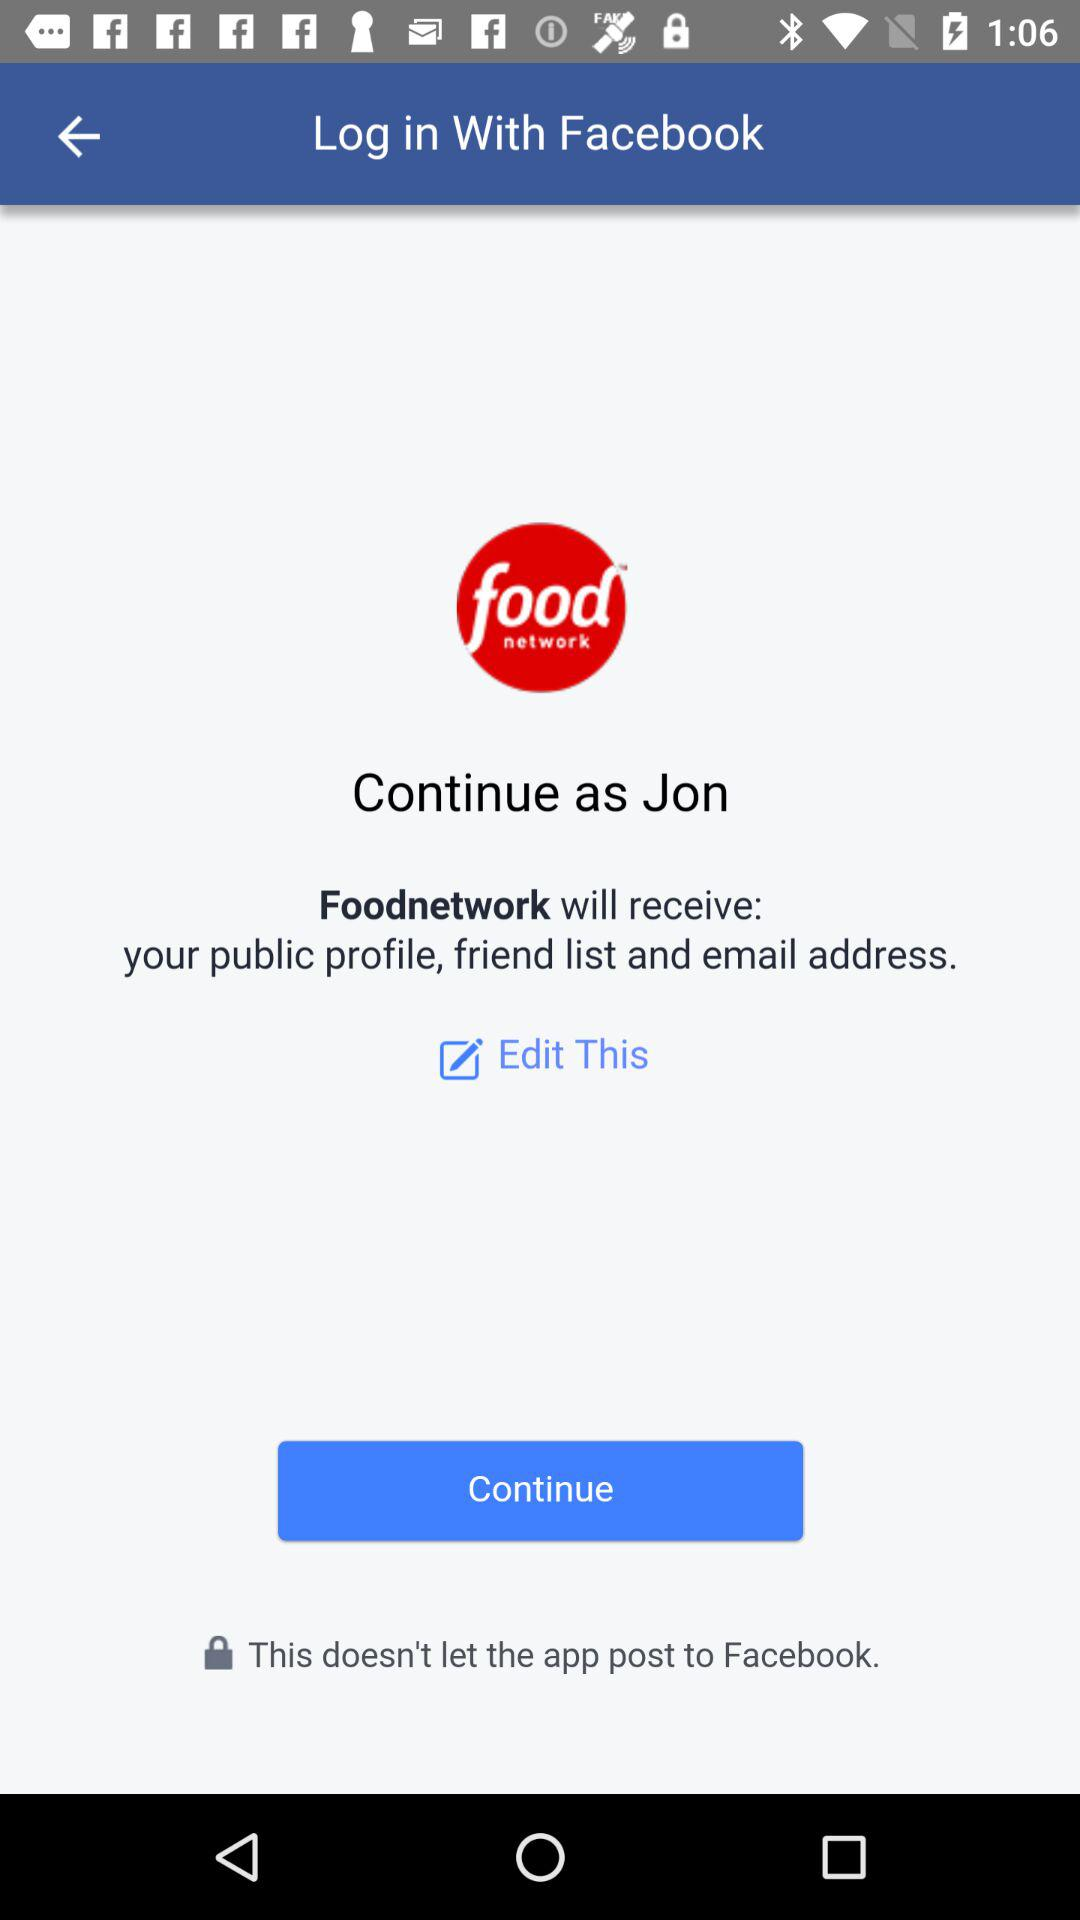Which application version is it?
When the provided information is insufficient, respond with <no answer>. <no answer> 